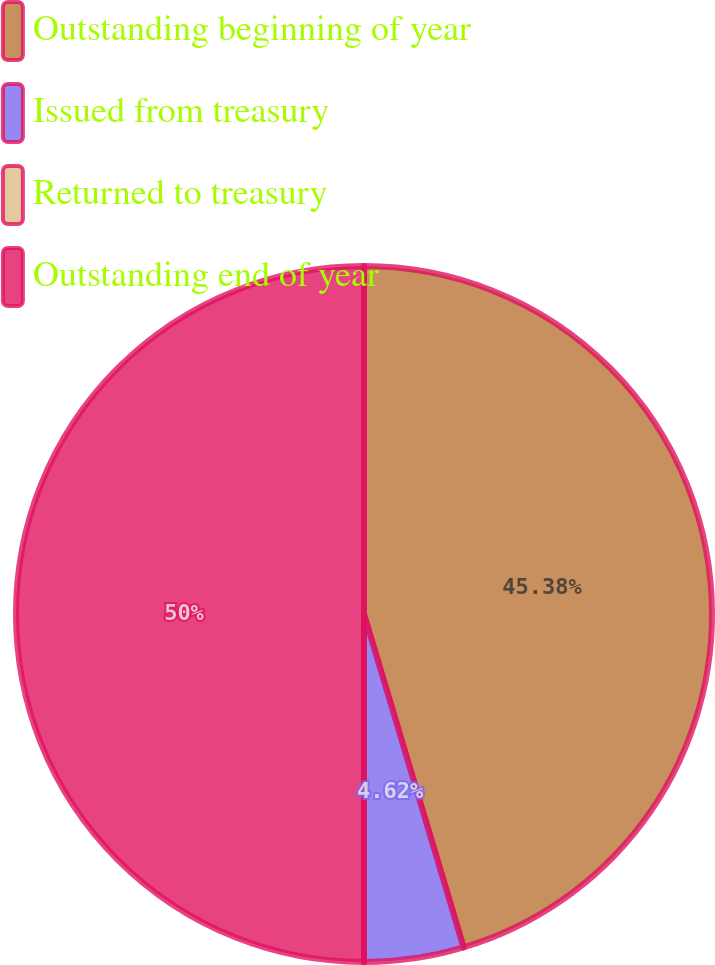Convert chart. <chart><loc_0><loc_0><loc_500><loc_500><pie_chart><fcel>Outstanding beginning of year<fcel>Issued from treasury<fcel>Returned to treasury<fcel>Outstanding end of year<nl><fcel>45.38%<fcel>4.62%<fcel>0.0%<fcel>50.0%<nl></chart> 